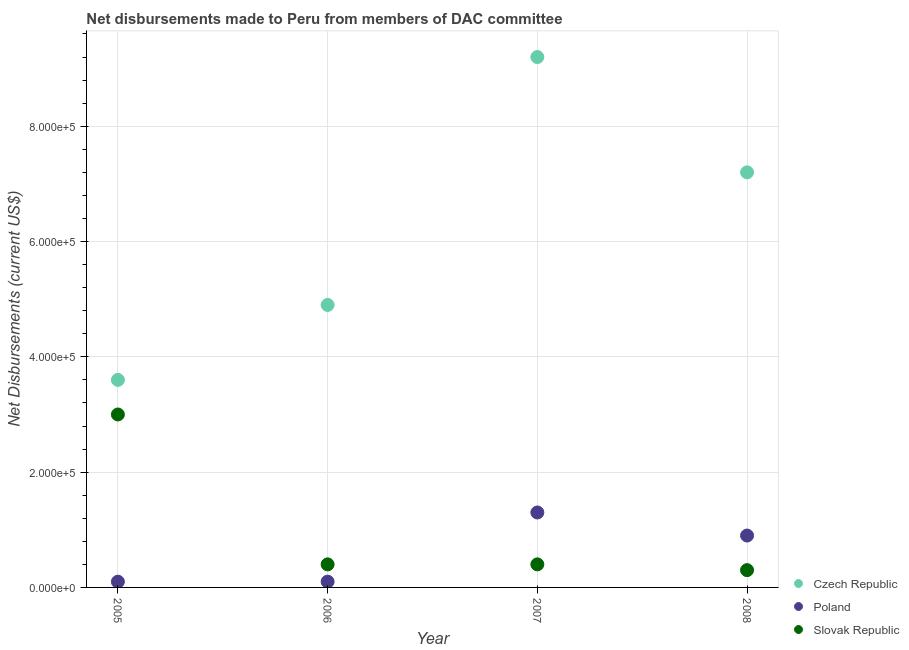Is the number of dotlines equal to the number of legend labels?
Give a very brief answer. Yes. What is the net disbursements made by czech republic in 2006?
Keep it short and to the point. 4.90e+05. Across all years, what is the maximum net disbursements made by poland?
Your response must be concise. 1.30e+05. Across all years, what is the minimum net disbursements made by poland?
Your response must be concise. 10000. In which year was the net disbursements made by czech republic maximum?
Offer a very short reply. 2007. In which year was the net disbursements made by poland minimum?
Your response must be concise. 2005. What is the total net disbursements made by slovak republic in the graph?
Your answer should be compact. 4.10e+05. What is the difference between the net disbursements made by slovak republic in 2006 and that in 2007?
Give a very brief answer. 0. What is the difference between the net disbursements made by slovak republic in 2007 and the net disbursements made by czech republic in 2006?
Provide a short and direct response. -4.50e+05. What is the average net disbursements made by slovak republic per year?
Offer a terse response. 1.02e+05. In the year 2006, what is the difference between the net disbursements made by czech republic and net disbursements made by poland?
Provide a succinct answer. 4.80e+05. What is the ratio of the net disbursements made by slovak republic in 2005 to that in 2007?
Keep it short and to the point. 7.5. What is the difference between the highest and the lowest net disbursements made by poland?
Your response must be concise. 1.20e+05. In how many years, is the net disbursements made by poland greater than the average net disbursements made by poland taken over all years?
Ensure brevity in your answer.  2. Is it the case that in every year, the sum of the net disbursements made by czech republic and net disbursements made by poland is greater than the net disbursements made by slovak republic?
Offer a terse response. Yes. Does the net disbursements made by poland monotonically increase over the years?
Make the answer very short. No. Does the graph contain any zero values?
Your answer should be compact. No. Does the graph contain grids?
Offer a very short reply. Yes. Where does the legend appear in the graph?
Offer a very short reply. Bottom right. How many legend labels are there?
Provide a succinct answer. 3. How are the legend labels stacked?
Provide a succinct answer. Vertical. What is the title of the graph?
Offer a very short reply. Net disbursements made to Peru from members of DAC committee. What is the label or title of the X-axis?
Make the answer very short. Year. What is the label or title of the Y-axis?
Make the answer very short. Net Disbursements (current US$). What is the Net Disbursements (current US$) in Poland in 2005?
Your answer should be compact. 10000. What is the Net Disbursements (current US$) of Slovak Republic in 2005?
Keep it short and to the point. 3.00e+05. What is the Net Disbursements (current US$) of Czech Republic in 2006?
Offer a terse response. 4.90e+05. What is the Net Disbursements (current US$) of Poland in 2006?
Give a very brief answer. 10000. What is the Net Disbursements (current US$) in Slovak Republic in 2006?
Give a very brief answer. 4.00e+04. What is the Net Disbursements (current US$) of Czech Republic in 2007?
Keep it short and to the point. 9.20e+05. What is the Net Disbursements (current US$) of Poland in 2007?
Ensure brevity in your answer.  1.30e+05. What is the Net Disbursements (current US$) in Czech Republic in 2008?
Ensure brevity in your answer.  7.20e+05. Across all years, what is the maximum Net Disbursements (current US$) in Czech Republic?
Your response must be concise. 9.20e+05. Across all years, what is the maximum Net Disbursements (current US$) in Slovak Republic?
Make the answer very short. 3.00e+05. Across all years, what is the minimum Net Disbursements (current US$) of Poland?
Your response must be concise. 10000. What is the total Net Disbursements (current US$) in Czech Republic in the graph?
Provide a succinct answer. 2.49e+06. What is the difference between the Net Disbursements (current US$) in Czech Republic in 2005 and that in 2006?
Keep it short and to the point. -1.30e+05. What is the difference between the Net Disbursements (current US$) of Slovak Republic in 2005 and that in 2006?
Your response must be concise. 2.60e+05. What is the difference between the Net Disbursements (current US$) in Czech Republic in 2005 and that in 2007?
Your answer should be very brief. -5.60e+05. What is the difference between the Net Disbursements (current US$) of Poland in 2005 and that in 2007?
Give a very brief answer. -1.20e+05. What is the difference between the Net Disbursements (current US$) in Czech Republic in 2005 and that in 2008?
Offer a very short reply. -3.60e+05. What is the difference between the Net Disbursements (current US$) in Slovak Republic in 2005 and that in 2008?
Ensure brevity in your answer.  2.70e+05. What is the difference between the Net Disbursements (current US$) in Czech Republic in 2006 and that in 2007?
Provide a succinct answer. -4.30e+05. What is the difference between the Net Disbursements (current US$) in Slovak Republic in 2006 and that in 2008?
Keep it short and to the point. 10000. What is the difference between the Net Disbursements (current US$) in Czech Republic in 2007 and that in 2008?
Make the answer very short. 2.00e+05. What is the difference between the Net Disbursements (current US$) in Poland in 2007 and that in 2008?
Give a very brief answer. 4.00e+04. What is the difference between the Net Disbursements (current US$) of Czech Republic in 2005 and the Net Disbursements (current US$) of Slovak Republic in 2006?
Your response must be concise. 3.20e+05. What is the difference between the Net Disbursements (current US$) of Czech Republic in 2005 and the Net Disbursements (current US$) of Poland in 2007?
Offer a very short reply. 2.30e+05. What is the difference between the Net Disbursements (current US$) in Czech Republic in 2005 and the Net Disbursements (current US$) in Slovak Republic in 2007?
Ensure brevity in your answer.  3.20e+05. What is the difference between the Net Disbursements (current US$) of Czech Republic in 2006 and the Net Disbursements (current US$) of Poland in 2007?
Give a very brief answer. 3.60e+05. What is the difference between the Net Disbursements (current US$) of Czech Republic in 2006 and the Net Disbursements (current US$) of Slovak Republic in 2007?
Keep it short and to the point. 4.50e+05. What is the difference between the Net Disbursements (current US$) of Poland in 2006 and the Net Disbursements (current US$) of Slovak Republic in 2007?
Provide a succinct answer. -3.00e+04. What is the difference between the Net Disbursements (current US$) of Poland in 2006 and the Net Disbursements (current US$) of Slovak Republic in 2008?
Your response must be concise. -2.00e+04. What is the difference between the Net Disbursements (current US$) of Czech Republic in 2007 and the Net Disbursements (current US$) of Poland in 2008?
Provide a succinct answer. 8.30e+05. What is the difference between the Net Disbursements (current US$) of Czech Republic in 2007 and the Net Disbursements (current US$) of Slovak Republic in 2008?
Provide a succinct answer. 8.90e+05. What is the difference between the Net Disbursements (current US$) of Poland in 2007 and the Net Disbursements (current US$) of Slovak Republic in 2008?
Make the answer very short. 1.00e+05. What is the average Net Disbursements (current US$) in Czech Republic per year?
Your response must be concise. 6.22e+05. What is the average Net Disbursements (current US$) of Poland per year?
Keep it short and to the point. 6.00e+04. What is the average Net Disbursements (current US$) of Slovak Republic per year?
Provide a succinct answer. 1.02e+05. In the year 2006, what is the difference between the Net Disbursements (current US$) in Czech Republic and Net Disbursements (current US$) in Slovak Republic?
Give a very brief answer. 4.50e+05. In the year 2007, what is the difference between the Net Disbursements (current US$) in Czech Republic and Net Disbursements (current US$) in Poland?
Make the answer very short. 7.90e+05. In the year 2007, what is the difference between the Net Disbursements (current US$) of Czech Republic and Net Disbursements (current US$) of Slovak Republic?
Give a very brief answer. 8.80e+05. In the year 2007, what is the difference between the Net Disbursements (current US$) in Poland and Net Disbursements (current US$) in Slovak Republic?
Provide a succinct answer. 9.00e+04. In the year 2008, what is the difference between the Net Disbursements (current US$) in Czech Republic and Net Disbursements (current US$) in Poland?
Keep it short and to the point. 6.30e+05. In the year 2008, what is the difference between the Net Disbursements (current US$) in Czech Republic and Net Disbursements (current US$) in Slovak Republic?
Your answer should be compact. 6.90e+05. In the year 2008, what is the difference between the Net Disbursements (current US$) in Poland and Net Disbursements (current US$) in Slovak Republic?
Your answer should be very brief. 6.00e+04. What is the ratio of the Net Disbursements (current US$) in Czech Republic in 2005 to that in 2006?
Make the answer very short. 0.73. What is the ratio of the Net Disbursements (current US$) in Poland in 2005 to that in 2006?
Make the answer very short. 1. What is the ratio of the Net Disbursements (current US$) of Slovak Republic in 2005 to that in 2006?
Provide a short and direct response. 7.5. What is the ratio of the Net Disbursements (current US$) of Czech Republic in 2005 to that in 2007?
Offer a terse response. 0.39. What is the ratio of the Net Disbursements (current US$) of Poland in 2005 to that in 2007?
Keep it short and to the point. 0.08. What is the ratio of the Net Disbursements (current US$) in Slovak Republic in 2005 to that in 2008?
Keep it short and to the point. 10. What is the ratio of the Net Disbursements (current US$) in Czech Republic in 2006 to that in 2007?
Make the answer very short. 0.53. What is the ratio of the Net Disbursements (current US$) in Poland in 2006 to that in 2007?
Offer a terse response. 0.08. What is the ratio of the Net Disbursements (current US$) of Slovak Republic in 2006 to that in 2007?
Ensure brevity in your answer.  1. What is the ratio of the Net Disbursements (current US$) of Czech Republic in 2006 to that in 2008?
Ensure brevity in your answer.  0.68. What is the ratio of the Net Disbursements (current US$) of Czech Republic in 2007 to that in 2008?
Your answer should be very brief. 1.28. What is the ratio of the Net Disbursements (current US$) in Poland in 2007 to that in 2008?
Your answer should be very brief. 1.44. What is the difference between the highest and the second highest Net Disbursements (current US$) in Czech Republic?
Provide a short and direct response. 2.00e+05. What is the difference between the highest and the second highest Net Disbursements (current US$) in Poland?
Your answer should be very brief. 4.00e+04. What is the difference between the highest and the second highest Net Disbursements (current US$) in Slovak Republic?
Make the answer very short. 2.60e+05. What is the difference between the highest and the lowest Net Disbursements (current US$) in Czech Republic?
Make the answer very short. 5.60e+05. What is the difference between the highest and the lowest Net Disbursements (current US$) in Poland?
Ensure brevity in your answer.  1.20e+05. What is the difference between the highest and the lowest Net Disbursements (current US$) in Slovak Republic?
Ensure brevity in your answer.  2.70e+05. 